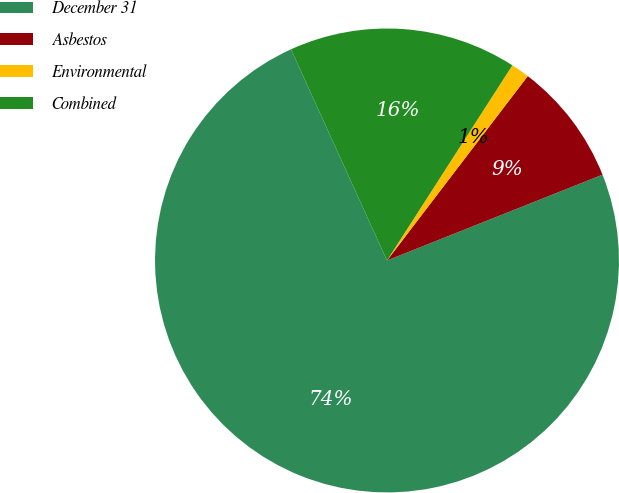<chart> <loc_0><loc_0><loc_500><loc_500><pie_chart><fcel>December 31<fcel>Asbestos<fcel>Environmental<fcel>Combined<nl><fcel>74.24%<fcel>8.59%<fcel>1.29%<fcel>15.88%<nl></chart> 